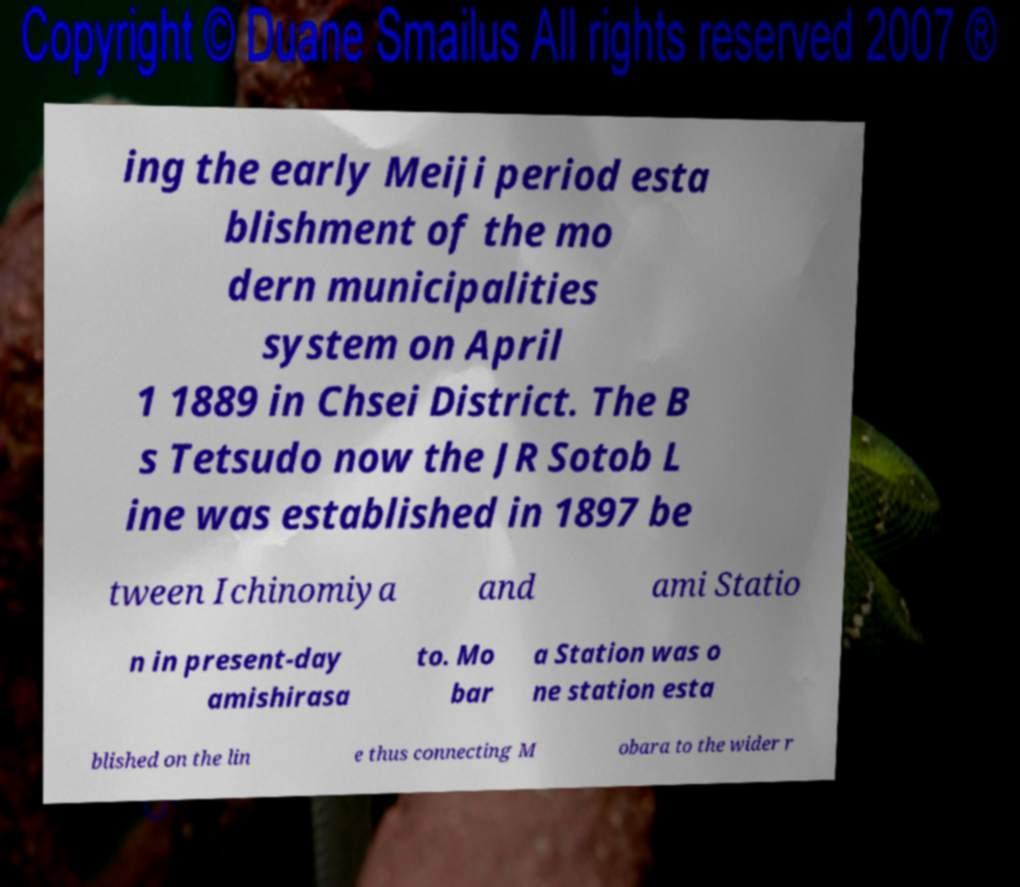What messages or text are displayed in this image? I need them in a readable, typed format. ing the early Meiji period esta blishment of the mo dern municipalities system on April 1 1889 in Chsei District. The B s Tetsudo now the JR Sotob L ine was established in 1897 be tween Ichinomiya and ami Statio n in present-day amishirasa to. Mo bar a Station was o ne station esta blished on the lin e thus connecting M obara to the wider r 